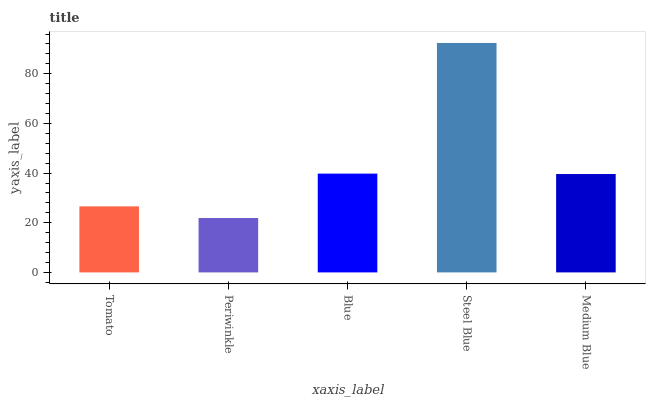Is Periwinkle the minimum?
Answer yes or no. Yes. Is Steel Blue the maximum?
Answer yes or no. Yes. Is Blue the minimum?
Answer yes or no. No. Is Blue the maximum?
Answer yes or no. No. Is Blue greater than Periwinkle?
Answer yes or no. Yes. Is Periwinkle less than Blue?
Answer yes or no. Yes. Is Periwinkle greater than Blue?
Answer yes or no. No. Is Blue less than Periwinkle?
Answer yes or no. No. Is Medium Blue the high median?
Answer yes or no. Yes. Is Medium Blue the low median?
Answer yes or no. Yes. Is Steel Blue the high median?
Answer yes or no. No. Is Blue the low median?
Answer yes or no. No. 